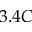<formula> <loc_0><loc_0><loc_500><loc_500>3 . 4 C</formula> 